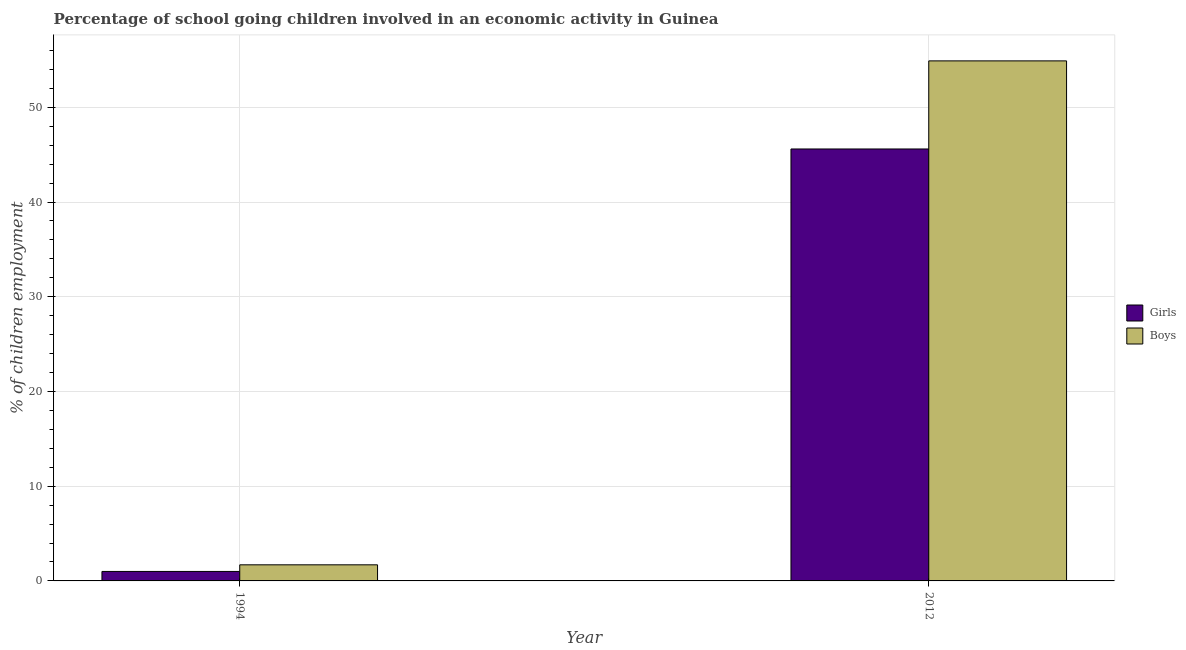How many different coloured bars are there?
Keep it short and to the point. 2. Are the number of bars per tick equal to the number of legend labels?
Offer a terse response. Yes. How many bars are there on the 1st tick from the left?
Your answer should be very brief. 2. How many bars are there on the 1st tick from the right?
Offer a terse response. 2. What is the label of the 1st group of bars from the left?
Make the answer very short. 1994. In how many cases, is the number of bars for a given year not equal to the number of legend labels?
Offer a terse response. 0. What is the percentage of school going girls in 2012?
Your answer should be compact. 45.6. Across all years, what is the maximum percentage of school going girls?
Ensure brevity in your answer.  45.6. Across all years, what is the minimum percentage of school going girls?
Offer a terse response. 1. In which year was the percentage of school going girls maximum?
Make the answer very short. 2012. In which year was the percentage of school going girls minimum?
Provide a short and direct response. 1994. What is the total percentage of school going boys in the graph?
Make the answer very short. 56.6. What is the difference between the percentage of school going girls in 1994 and that in 2012?
Offer a very short reply. -44.6. What is the difference between the percentage of school going girls in 1994 and the percentage of school going boys in 2012?
Your response must be concise. -44.6. What is the average percentage of school going boys per year?
Your response must be concise. 28.3. In the year 1994, what is the difference between the percentage of school going girls and percentage of school going boys?
Your response must be concise. 0. What is the ratio of the percentage of school going boys in 1994 to that in 2012?
Keep it short and to the point. 0.03. Is the percentage of school going girls in 1994 less than that in 2012?
Give a very brief answer. Yes. What does the 1st bar from the left in 2012 represents?
Provide a short and direct response. Girls. What does the 1st bar from the right in 1994 represents?
Keep it short and to the point. Boys. Are all the bars in the graph horizontal?
Your answer should be very brief. No. How many years are there in the graph?
Offer a very short reply. 2. Does the graph contain any zero values?
Make the answer very short. No. Does the graph contain grids?
Your answer should be very brief. Yes. How are the legend labels stacked?
Make the answer very short. Vertical. What is the title of the graph?
Make the answer very short. Percentage of school going children involved in an economic activity in Guinea. Does "Imports" appear as one of the legend labels in the graph?
Your response must be concise. No. What is the label or title of the Y-axis?
Ensure brevity in your answer.  % of children employment. What is the % of children employment of Girls in 1994?
Give a very brief answer. 1. What is the % of children employment in Boys in 1994?
Ensure brevity in your answer.  1.7. What is the % of children employment in Girls in 2012?
Provide a short and direct response. 45.6. What is the % of children employment of Boys in 2012?
Ensure brevity in your answer.  54.9. Across all years, what is the maximum % of children employment in Girls?
Keep it short and to the point. 45.6. Across all years, what is the maximum % of children employment in Boys?
Give a very brief answer. 54.9. What is the total % of children employment of Girls in the graph?
Offer a very short reply. 46.6. What is the total % of children employment of Boys in the graph?
Your response must be concise. 56.6. What is the difference between the % of children employment of Girls in 1994 and that in 2012?
Offer a very short reply. -44.6. What is the difference between the % of children employment of Boys in 1994 and that in 2012?
Your answer should be compact. -53.2. What is the difference between the % of children employment in Girls in 1994 and the % of children employment in Boys in 2012?
Ensure brevity in your answer.  -53.9. What is the average % of children employment in Girls per year?
Give a very brief answer. 23.3. What is the average % of children employment of Boys per year?
Keep it short and to the point. 28.3. In the year 1994, what is the difference between the % of children employment of Girls and % of children employment of Boys?
Give a very brief answer. -0.7. What is the ratio of the % of children employment of Girls in 1994 to that in 2012?
Make the answer very short. 0.02. What is the ratio of the % of children employment of Boys in 1994 to that in 2012?
Offer a very short reply. 0.03. What is the difference between the highest and the second highest % of children employment of Girls?
Provide a succinct answer. 44.6. What is the difference between the highest and the second highest % of children employment in Boys?
Offer a terse response. 53.2. What is the difference between the highest and the lowest % of children employment in Girls?
Offer a very short reply. 44.6. What is the difference between the highest and the lowest % of children employment of Boys?
Provide a succinct answer. 53.2. 